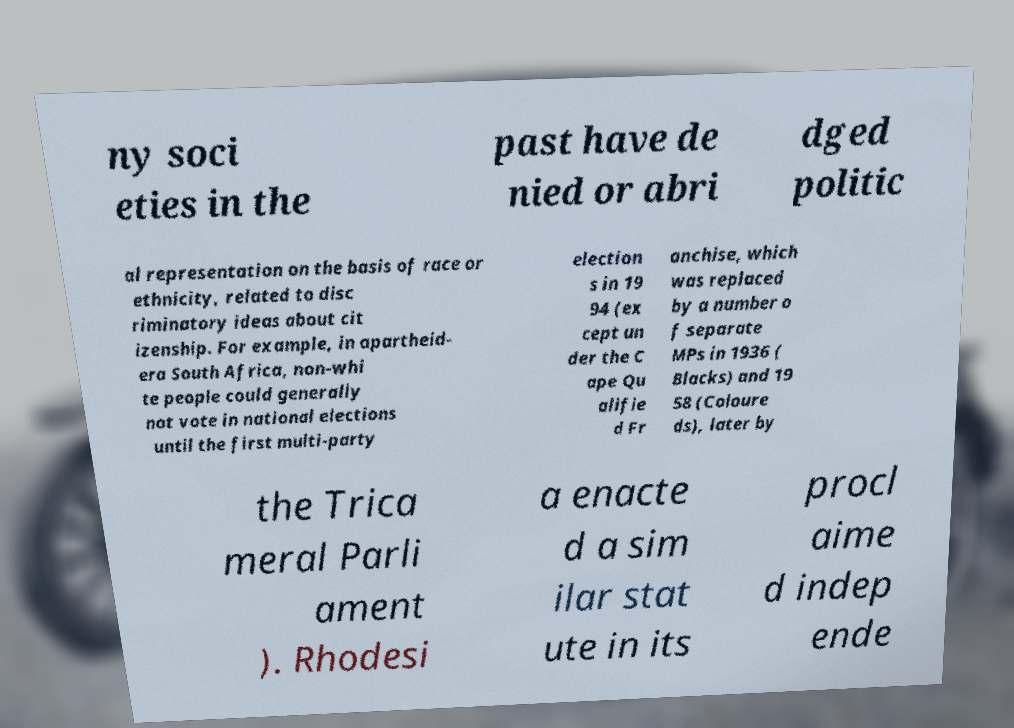Please read and relay the text visible in this image. What does it say? ny soci eties in the past have de nied or abri dged politic al representation on the basis of race or ethnicity, related to disc riminatory ideas about cit izenship. For example, in apartheid- era South Africa, non-whi te people could generally not vote in national elections until the first multi-party election s in 19 94 (ex cept un der the C ape Qu alifie d Fr anchise, which was replaced by a number o f separate MPs in 1936 ( Blacks) and 19 58 (Coloure ds), later by the Trica meral Parli ament ). Rhodesi a enacte d a sim ilar stat ute in its procl aime d indep ende 